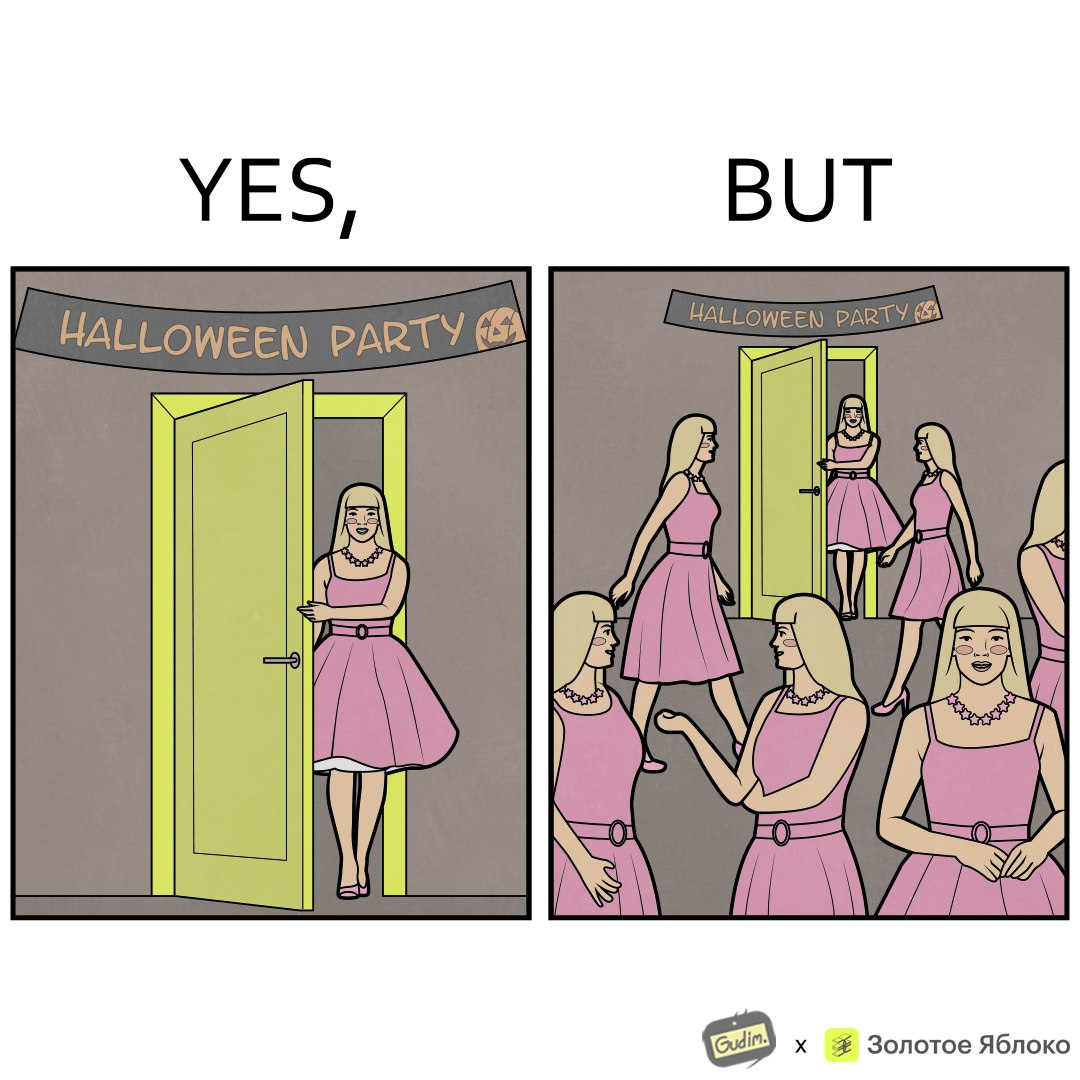Does this image contain satire or humor? Yes, this image is satirical. 